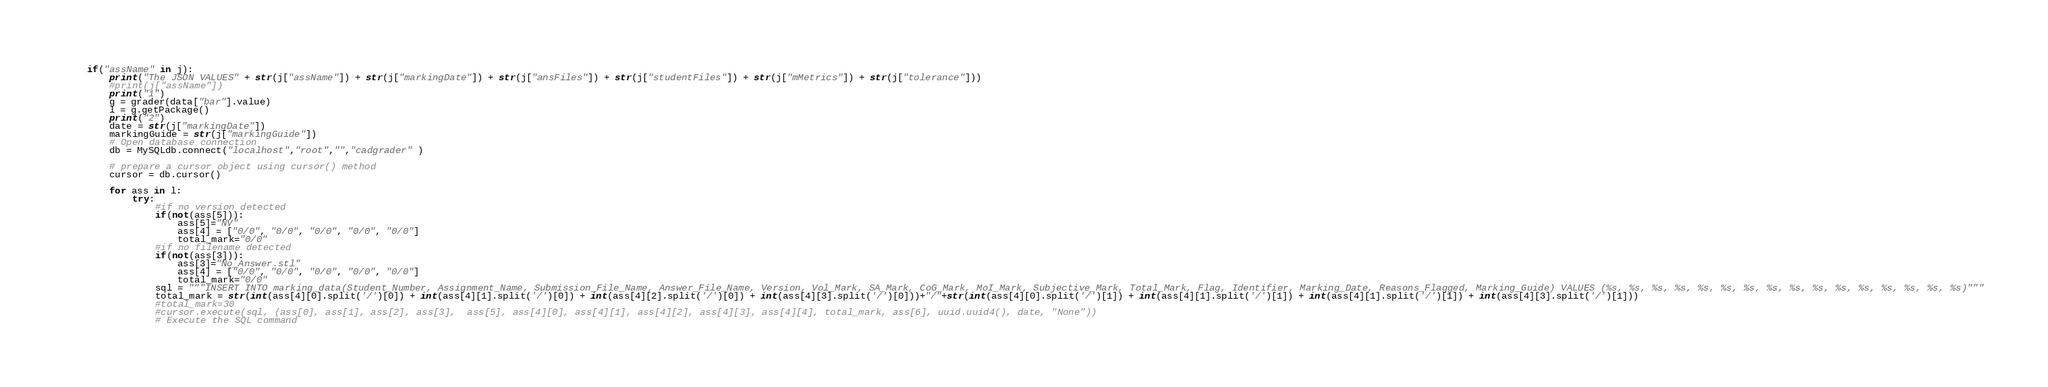<code> <loc_0><loc_0><loc_500><loc_500><_Python_>    if("assName" in j):
        print("The JSON VALUES" + str(j["assName"]) + str(j["markingDate"]) + str(j["ansFiles"]) + str(j["studentFiles"]) + str(j["mMetrics"]) + str(j["tolerance"]))       
        #print(j["assName"])
        print("1")
        g = grader(data["bar"].value)
        l = g.getPackage()
        print("2")
        date = str(j["markingDate"])
        markingGuide = str(j["markingGuide"])
        # Open database connection
        db = MySQLdb.connect("localhost","root","","cadgrader" )

        # prepare a cursor object using cursor() method
        cursor = db.cursor()

        for ass in l:
            try:
                #if no version detected
                if(not(ass[5])):
                    ass[5]="NV"
                    ass[4] = ["0/0", "0/0", "0/0", "0/0", "0/0"]
                    total_mark="0/0"
                #if no filename detected
                if(not(ass[3])):
                    ass[3]="No_Answer.stl"
                    ass[4] = ["0/0", "0/0", "0/0", "0/0", "0/0"]
                    total_mark="0/0"
                sql = """INSERT INTO marking_data(Student_Number, Assignment_Name, Submission_File_Name, Answer_File_Name, Version, Vol_Mark, SA_Mark, CoG_Mark, MoI_Mark, Subjective_Mark, Total_Mark, Flag, Identifier, Marking_Date, Reasons_Flagged, Marking_Guide) VALUES (%s, %s, %s, %s, %s, %s, %s, %s, %s, %s, %s, %s, %s, %s, %s, %s)"""
                total_mark = str(int(ass[4][0].split('/')[0]) + int(ass[4][1].split('/')[0]) + int(ass[4][2].split('/')[0]) + int(ass[4][3].split('/')[0]))+"/"+str(int(ass[4][0].split('/')[1]) + int(ass[4][1].split('/')[1]) + int(ass[4][1].split('/')[1]) + int(ass[4][3].split('/')[1]))
                #total_mark=30
                #cursor.execute(sql, (ass[0], ass[1], ass[2], ass[3],  ass[5], ass[4][0], ass[4][1], ass[4][2], ass[4][3], ass[4][4], total_mark, ass[6], uuid.uuid4(), date, "None"))
                # Execute the SQL command</code> 